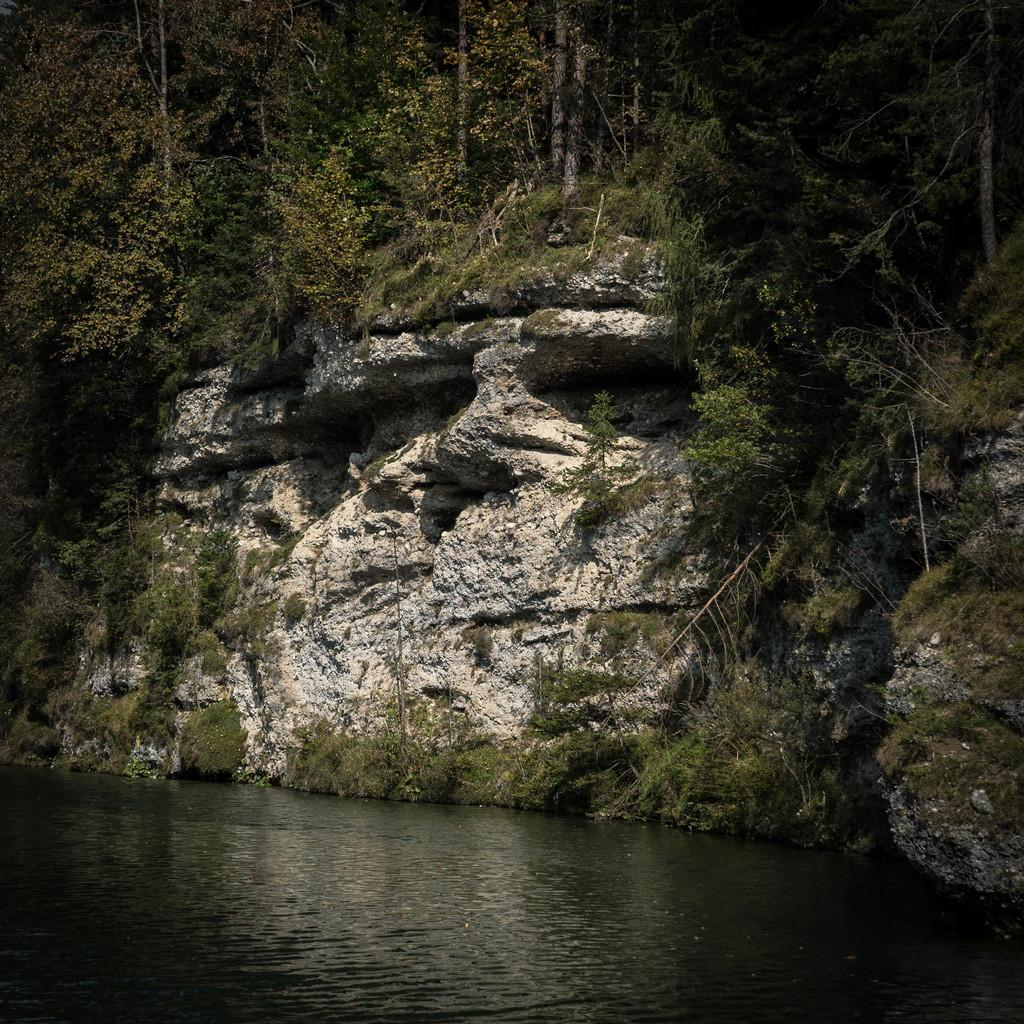What is the main geographical feature in the image? There is a hill in the image. What type of vegetation is present around the hill? There are trees around the hill. What can be seen in the foreground of the image? There is a water surface in the foreground of the image. Where is the shop located in the image? There is no shop present in the image. What color are the eggs on the hill? There are no eggs present in the image. 